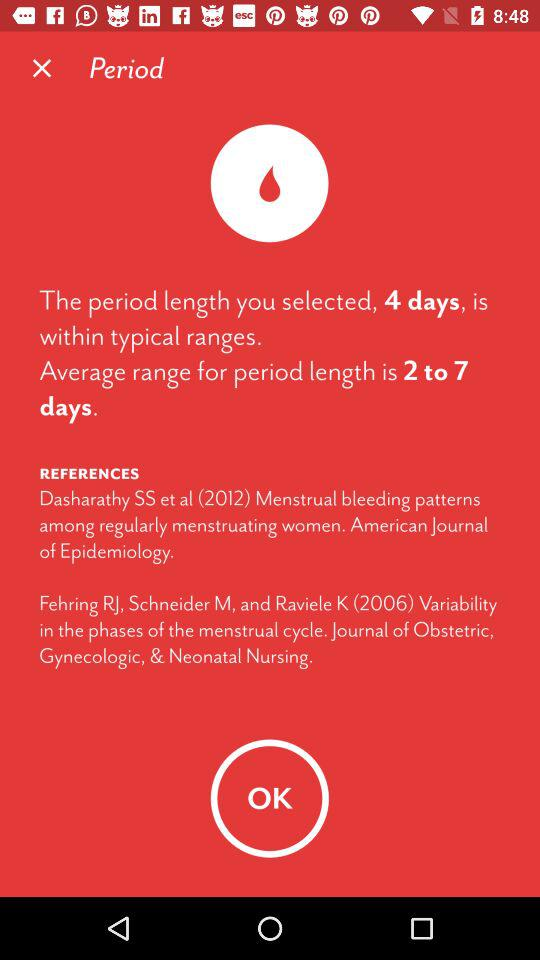What is the average range for period length? The average range is 2 to 7 days. 